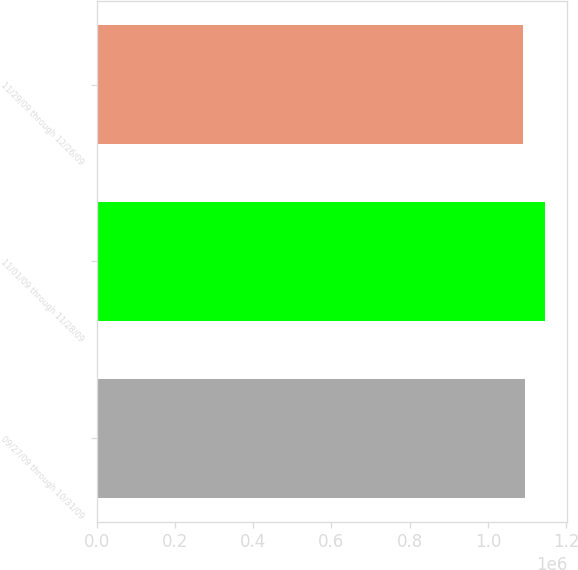<chart> <loc_0><loc_0><loc_500><loc_500><bar_chart><fcel>09/27/09 through 10/31/09<fcel>11/01/09 through 11/28/09<fcel>11/29/09 through 12/26/09<nl><fcel>1.09485e+06<fcel>1.14623e+06<fcel>1.08914e+06<nl></chart> 